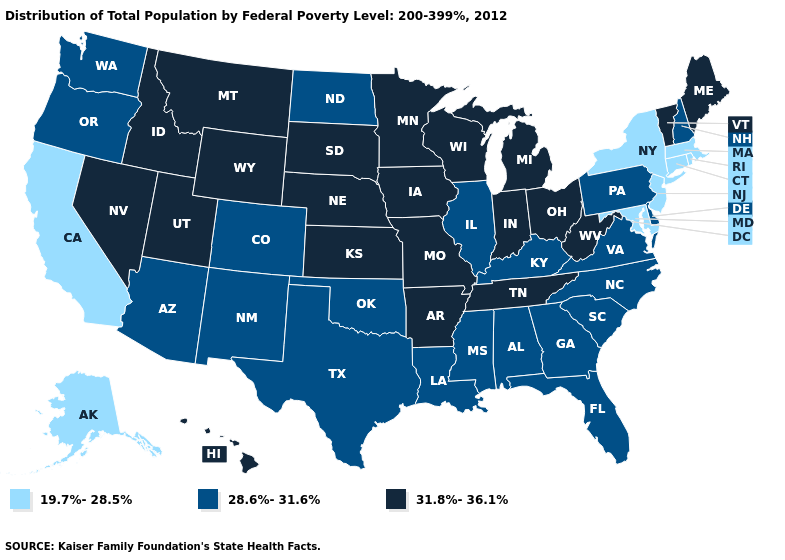Name the states that have a value in the range 28.6%-31.6%?
Keep it brief. Alabama, Arizona, Colorado, Delaware, Florida, Georgia, Illinois, Kentucky, Louisiana, Mississippi, New Hampshire, New Mexico, North Carolina, North Dakota, Oklahoma, Oregon, Pennsylvania, South Carolina, Texas, Virginia, Washington. What is the value of Maine?
Quick response, please. 31.8%-36.1%. How many symbols are there in the legend?
Be succinct. 3. What is the value of Iowa?
Concise answer only. 31.8%-36.1%. Does New Jersey have the same value as Maryland?
Answer briefly. Yes. Name the states that have a value in the range 19.7%-28.5%?
Give a very brief answer. Alaska, California, Connecticut, Maryland, Massachusetts, New Jersey, New York, Rhode Island. Is the legend a continuous bar?
Write a very short answer. No. Is the legend a continuous bar?
Write a very short answer. No. What is the lowest value in the USA?
Keep it brief. 19.7%-28.5%. What is the highest value in states that border Oklahoma?
Concise answer only. 31.8%-36.1%. Name the states that have a value in the range 31.8%-36.1%?
Keep it brief. Arkansas, Hawaii, Idaho, Indiana, Iowa, Kansas, Maine, Michigan, Minnesota, Missouri, Montana, Nebraska, Nevada, Ohio, South Dakota, Tennessee, Utah, Vermont, West Virginia, Wisconsin, Wyoming. What is the highest value in the USA?
Give a very brief answer. 31.8%-36.1%. Name the states that have a value in the range 19.7%-28.5%?
Be succinct. Alaska, California, Connecticut, Maryland, Massachusetts, New Jersey, New York, Rhode Island. Name the states that have a value in the range 31.8%-36.1%?
Answer briefly. Arkansas, Hawaii, Idaho, Indiana, Iowa, Kansas, Maine, Michigan, Minnesota, Missouri, Montana, Nebraska, Nevada, Ohio, South Dakota, Tennessee, Utah, Vermont, West Virginia, Wisconsin, Wyoming. Name the states that have a value in the range 31.8%-36.1%?
Give a very brief answer. Arkansas, Hawaii, Idaho, Indiana, Iowa, Kansas, Maine, Michigan, Minnesota, Missouri, Montana, Nebraska, Nevada, Ohio, South Dakota, Tennessee, Utah, Vermont, West Virginia, Wisconsin, Wyoming. 